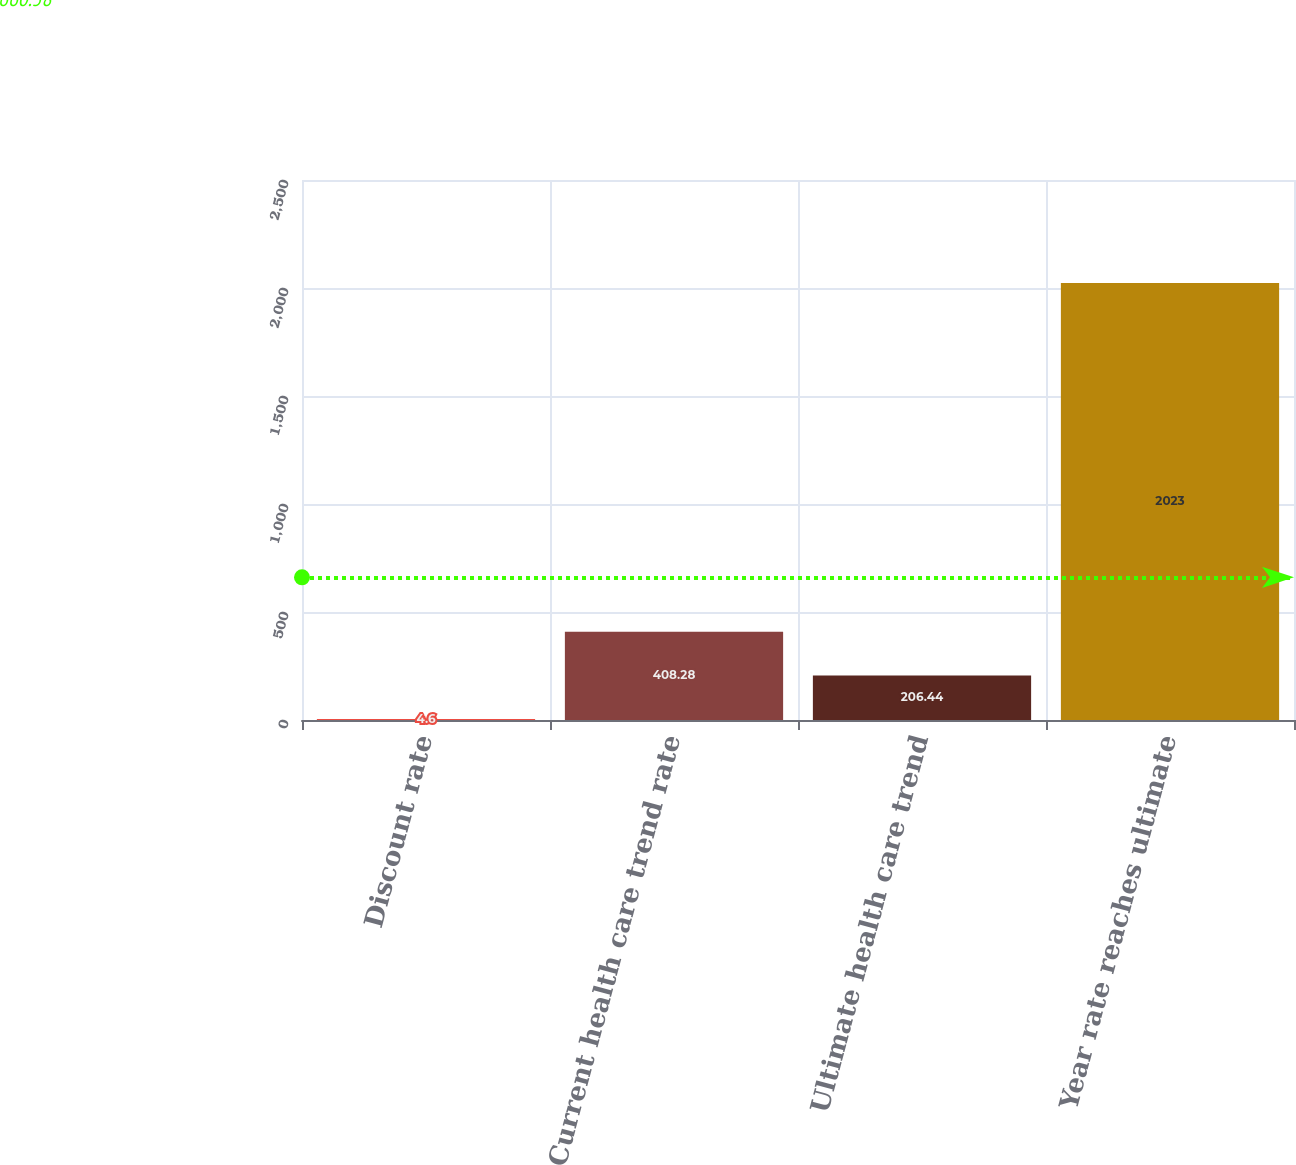<chart> <loc_0><loc_0><loc_500><loc_500><bar_chart><fcel>Discount rate<fcel>Current health care trend rate<fcel>Ultimate health care trend<fcel>Year rate reaches ultimate<nl><fcel>4.6<fcel>408.28<fcel>206.44<fcel>2023<nl></chart> 